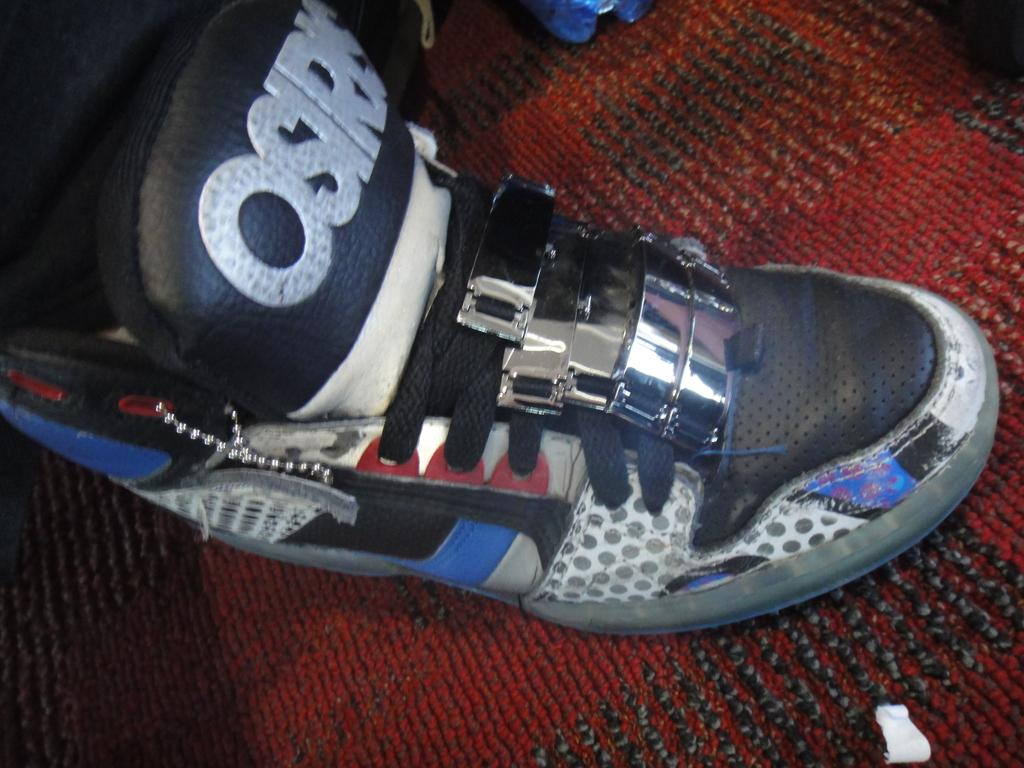<image>
Relay a brief, clear account of the picture shown. The brand of shoe shown here is from Osiris 